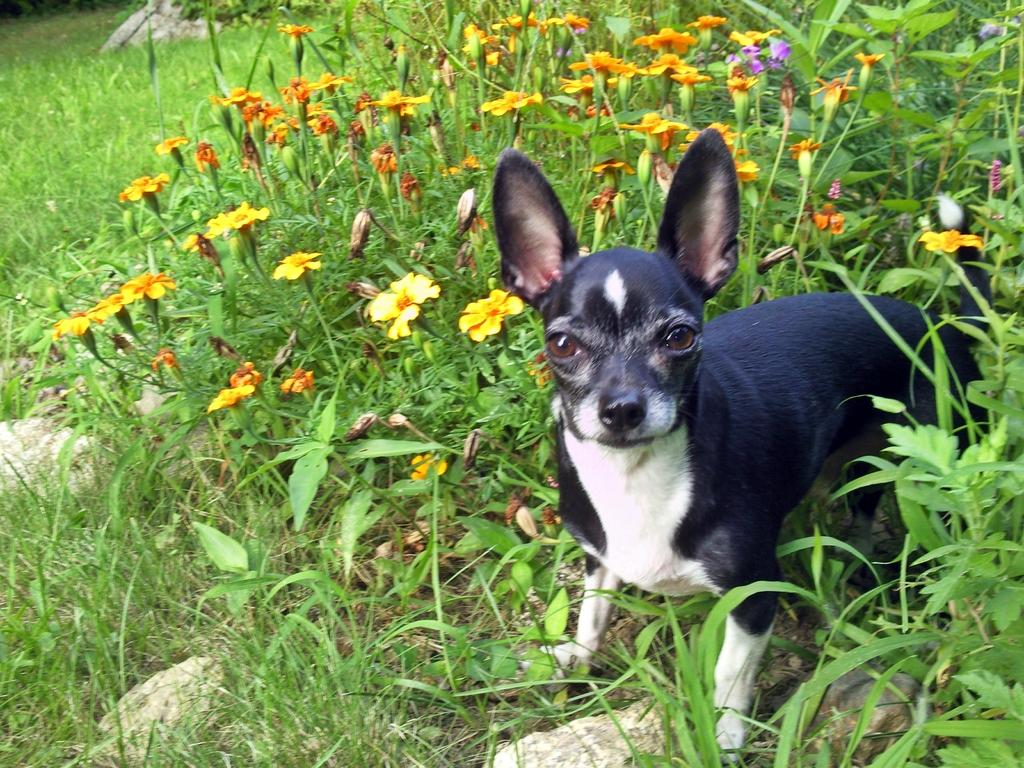What type of vegetation is present in the image? There are plants with leaves and flowers in the image. What animal can be seen in the image? There is a dog in the image. What is the ground made of in the image? There is grass and stones on the ground in the image. Can you see a station or train in the image? No, there is no station or train present in the image. Is the dog walking on the seashore in the image? The image only shows one dog, so there is only one person (the dog) in the image. 